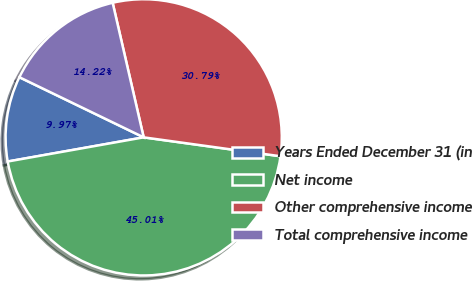Convert chart to OTSL. <chart><loc_0><loc_0><loc_500><loc_500><pie_chart><fcel>Years Ended December 31 (in<fcel>Net income<fcel>Other comprehensive income<fcel>Total comprehensive income<nl><fcel>9.97%<fcel>45.01%<fcel>30.79%<fcel>14.22%<nl></chart> 